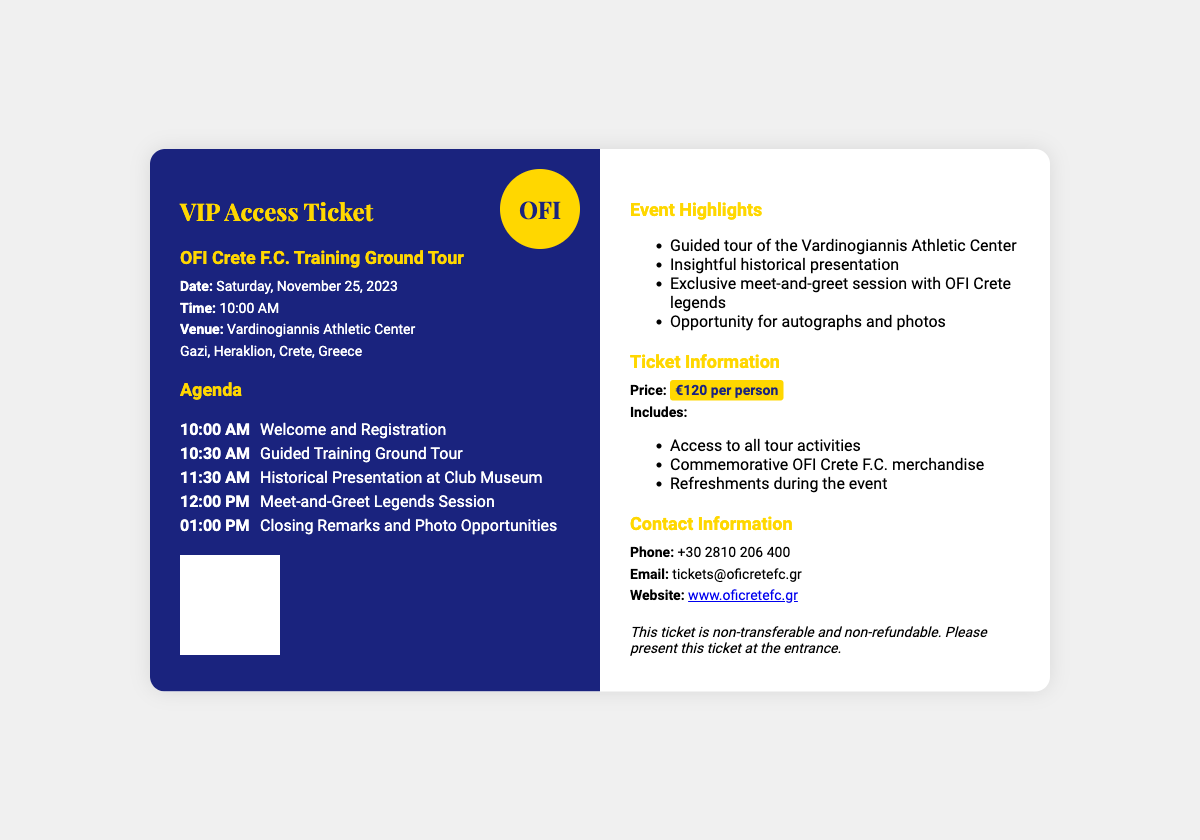What is the date of the event? The document clearly states that the event is on Saturday, November 25, 2023.
Answer: November 25, 2023 What time does the guided training ground tour start? According to the agenda, the guided training ground tour begins at 10:30 AM.
Answer: 10:30 AM What is the price of the VIP Access Ticket? The ticket information specifies that the price is €120 per person.
Answer: €120 What is included with the ticket? The document lists three items included with the ticket: access to tour activities, commemorative merchandise, and refreshments.
Answer: Access to all tour activities, commemorative OFI Crete F.C. merchandise, refreshments Where is the venue located? The venue for the event is identified as the Vardinogiannis Athletic Center in Gazi, Heraklion, Crete, Greece.
Answer: Vardinogiannis Athletic Center, Gazi, Heraklion, Crete, Greece What is one of the highlights of the event? The document mentions several event highlights, one of which is the exclusive meet-and-greet session with OFI Crete legends.
Answer: Exclusive meet-and-greet session with OFI Crete legends What time does the photo opportunity occur? The agenda indicates that photo opportunities will occur at 1:00 PM after closing remarks.
Answer: 01:00 PM 